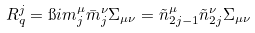Convert formula to latex. <formula><loc_0><loc_0><loc_500><loc_500>R ^ { j } _ { q } = \i i m _ { j } ^ { \mu } \bar { m } _ { j } ^ { \nu } \Sigma _ { \mu \nu } = \tilde { n } _ { 2 j - 1 } ^ { \mu } \tilde { n } _ { 2 j } ^ { \nu } \Sigma _ { \mu \nu }</formula> 